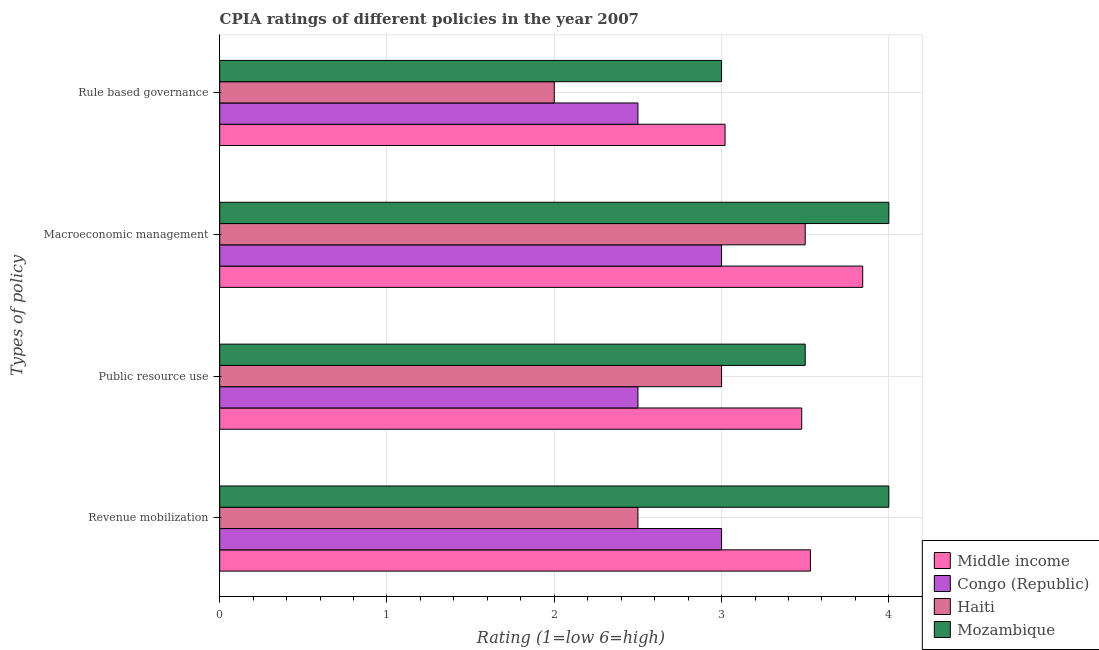How many different coloured bars are there?
Offer a terse response. 4. Are the number of bars on each tick of the Y-axis equal?
Provide a short and direct response. Yes. How many bars are there on the 2nd tick from the top?
Offer a very short reply. 4. What is the label of the 2nd group of bars from the top?
Offer a very short reply. Macroeconomic management. What is the cpia rating of macroeconomic management in Middle income?
Offer a terse response. 3.84. Across all countries, what is the maximum cpia rating of macroeconomic management?
Your answer should be very brief. 4. Across all countries, what is the minimum cpia rating of revenue mobilization?
Your answer should be compact. 2.5. In which country was the cpia rating of macroeconomic management maximum?
Make the answer very short. Mozambique. In which country was the cpia rating of macroeconomic management minimum?
Keep it short and to the point. Congo (Republic). What is the total cpia rating of public resource use in the graph?
Your answer should be compact. 12.48. What is the difference between the cpia rating of revenue mobilization in Middle income and the cpia rating of rule based governance in Haiti?
Provide a succinct answer. 1.53. What is the average cpia rating of macroeconomic management per country?
Your answer should be compact. 3.59. What is the ratio of the cpia rating of public resource use in Congo (Republic) to that in Middle income?
Offer a very short reply. 0.72. Is the difference between the cpia rating of macroeconomic management in Middle income and Congo (Republic) greater than the difference between the cpia rating of public resource use in Middle income and Congo (Republic)?
Ensure brevity in your answer.  No. What is the difference between the highest and the second highest cpia rating of public resource use?
Your response must be concise. 0.02. In how many countries, is the cpia rating of public resource use greater than the average cpia rating of public resource use taken over all countries?
Keep it short and to the point. 2. Is the sum of the cpia rating of public resource use in Middle income and Haiti greater than the maximum cpia rating of rule based governance across all countries?
Make the answer very short. Yes. What does the 2nd bar from the top in Revenue mobilization represents?
Give a very brief answer. Haiti. What does the 4th bar from the bottom in Macroeconomic management represents?
Provide a succinct answer. Mozambique. How many bars are there?
Provide a succinct answer. 16. What is the difference between two consecutive major ticks on the X-axis?
Offer a terse response. 1. Are the values on the major ticks of X-axis written in scientific E-notation?
Your answer should be compact. No. Does the graph contain grids?
Your response must be concise. Yes. How many legend labels are there?
Offer a terse response. 4. What is the title of the graph?
Ensure brevity in your answer.  CPIA ratings of different policies in the year 2007. What is the label or title of the Y-axis?
Ensure brevity in your answer.  Types of policy. What is the Rating (1=low 6=high) of Middle income in Revenue mobilization?
Keep it short and to the point. 3.53. What is the Rating (1=low 6=high) in Haiti in Revenue mobilization?
Your answer should be very brief. 2.5. What is the Rating (1=low 6=high) of Middle income in Public resource use?
Your answer should be very brief. 3.48. What is the Rating (1=low 6=high) in Congo (Republic) in Public resource use?
Your answer should be very brief. 2.5. What is the Rating (1=low 6=high) in Haiti in Public resource use?
Offer a terse response. 3. What is the Rating (1=low 6=high) of Mozambique in Public resource use?
Make the answer very short. 3.5. What is the Rating (1=low 6=high) in Middle income in Macroeconomic management?
Your answer should be compact. 3.84. What is the Rating (1=low 6=high) of Congo (Republic) in Macroeconomic management?
Your answer should be very brief. 3. What is the Rating (1=low 6=high) of Middle income in Rule based governance?
Offer a very short reply. 3.02. What is the Rating (1=low 6=high) of Haiti in Rule based governance?
Offer a terse response. 2. Across all Types of policy, what is the maximum Rating (1=low 6=high) in Middle income?
Offer a very short reply. 3.84. Across all Types of policy, what is the maximum Rating (1=low 6=high) in Congo (Republic)?
Keep it short and to the point. 3. Across all Types of policy, what is the maximum Rating (1=low 6=high) of Mozambique?
Your answer should be very brief. 4. Across all Types of policy, what is the minimum Rating (1=low 6=high) in Middle income?
Your answer should be very brief. 3.02. What is the total Rating (1=low 6=high) in Middle income in the graph?
Offer a terse response. 13.88. What is the total Rating (1=low 6=high) in Congo (Republic) in the graph?
Provide a succinct answer. 11. What is the total Rating (1=low 6=high) in Haiti in the graph?
Keep it short and to the point. 11. What is the total Rating (1=low 6=high) in Mozambique in the graph?
Give a very brief answer. 14.5. What is the difference between the Rating (1=low 6=high) in Middle income in Revenue mobilization and that in Public resource use?
Provide a short and direct response. 0.05. What is the difference between the Rating (1=low 6=high) of Congo (Republic) in Revenue mobilization and that in Public resource use?
Keep it short and to the point. 0.5. What is the difference between the Rating (1=low 6=high) of Haiti in Revenue mobilization and that in Public resource use?
Ensure brevity in your answer.  -0.5. What is the difference between the Rating (1=low 6=high) in Middle income in Revenue mobilization and that in Macroeconomic management?
Your answer should be compact. -0.31. What is the difference between the Rating (1=low 6=high) of Congo (Republic) in Revenue mobilization and that in Macroeconomic management?
Give a very brief answer. 0. What is the difference between the Rating (1=low 6=high) in Middle income in Revenue mobilization and that in Rule based governance?
Your response must be concise. 0.51. What is the difference between the Rating (1=low 6=high) of Mozambique in Revenue mobilization and that in Rule based governance?
Give a very brief answer. 1. What is the difference between the Rating (1=low 6=high) in Middle income in Public resource use and that in Macroeconomic management?
Your response must be concise. -0.36. What is the difference between the Rating (1=low 6=high) in Mozambique in Public resource use and that in Macroeconomic management?
Ensure brevity in your answer.  -0.5. What is the difference between the Rating (1=low 6=high) of Middle income in Public resource use and that in Rule based governance?
Give a very brief answer. 0.46. What is the difference between the Rating (1=low 6=high) in Congo (Republic) in Public resource use and that in Rule based governance?
Offer a terse response. 0. What is the difference between the Rating (1=low 6=high) in Haiti in Public resource use and that in Rule based governance?
Keep it short and to the point. 1. What is the difference between the Rating (1=low 6=high) of Middle income in Macroeconomic management and that in Rule based governance?
Offer a very short reply. 0.82. What is the difference between the Rating (1=low 6=high) in Congo (Republic) in Macroeconomic management and that in Rule based governance?
Provide a short and direct response. 0.5. What is the difference between the Rating (1=low 6=high) in Mozambique in Macroeconomic management and that in Rule based governance?
Your answer should be compact. 1. What is the difference between the Rating (1=low 6=high) in Middle income in Revenue mobilization and the Rating (1=low 6=high) in Congo (Republic) in Public resource use?
Offer a terse response. 1.03. What is the difference between the Rating (1=low 6=high) in Middle income in Revenue mobilization and the Rating (1=low 6=high) in Haiti in Public resource use?
Make the answer very short. 0.53. What is the difference between the Rating (1=low 6=high) in Middle income in Revenue mobilization and the Rating (1=low 6=high) in Mozambique in Public resource use?
Keep it short and to the point. 0.03. What is the difference between the Rating (1=low 6=high) of Congo (Republic) in Revenue mobilization and the Rating (1=low 6=high) of Haiti in Public resource use?
Ensure brevity in your answer.  0. What is the difference between the Rating (1=low 6=high) in Congo (Republic) in Revenue mobilization and the Rating (1=low 6=high) in Mozambique in Public resource use?
Provide a short and direct response. -0.5. What is the difference between the Rating (1=low 6=high) in Middle income in Revenue mobilization and the Rating (1=low 6=high) in Congo (Republic) in Macroeconomic management?
Your response must be concise. 0.53. What is the difference between the Rating (1=low 6=high) in Middle income in Revenue mobilization and the Rating (1=low 6=high) in Haiti in Macroeconomic management?
Offer a terse response. 0.03. What is the difference between the Rating (1=low 6=high) of Middle income in Revenue mobilization and the Rating (1=low 6=high) of Mozambique in Macroeconomic management?
Offer a very short reply. -0.47. What is the difference between the Rating (1=low 6=high) in Congo (Republic) in Revenue mobilization and the Rating (1=low 6=high) in Haiti in Macroeconomic management?
Your answer should be very brief. -0.5. What is the difference between the Rating (1=low 6=high) in Congo (Republic) in Revenue mobilization and the Rating (1=low 6=high) in Mozambique in Macroeconomic management?
Offer a very short reply. -1. What is the difference between the Rating (1=low 6=high) of Middle income in Revenue mobilization and the Rating (1=low 6=high) of Congo (Republic) in Rule based governance?
Offer a terse response. 1.03. What is the difference between the Rating (1=low 6=high) of Middle income in Revenue mobilization and the Rating (1=low 6=high) of Haiti in Rule based governance?
Provide a succinct answer. 1.53. What is the difference between the Rating (1=low 6=high) of Middle income in Revenue mobilization and the Rating (1=low 6=high) of Mozambique in Rule based governance?
Keep it short and to the point. 0.53. What is the difference between the Rating (1=low 6=high) of Congo (Republic) in Revenue mobilization and the Rating (1=low 6=high) of Haiti in Rule based governance?
Provide a short and direct response. 1. What is the difference between the Rating (1=low 6=high) in Congo (Republic) in Revenue mobilization and the Rating (1=low 6=high) in Mozambique in Rule based governance?
Provide a succinct answer. 0. What is the difference between the Rating (1=low 6=high) of Middle income in Public resource use and the Rating (1=low 6=high) of Congo (Republic) in Macroeconomic management?
Your response must be concise. 0.48. What is the difference between the Rating (1=low 6=high) in Middle income in Public resource use and the Rating (1=low 6=high) in Haiti in Macroeconomic management?
Keep it short and to the point. -0.02. What is the difference between the Rating (1=low 6=high) in Middle income in Public resource use and the Rating (1=low 6=high) in Mozambique in Macroeconomic management?
Provide a succinct answer. -0.52. What is the difference between the Rating (1=low 6=high) of Congo (Republic) in Public resource use and the Rating (1=low 6=high) of Haiti in Macroeconomic management?
Your answer should be very brief. -1. What is the difference between the Rating (1=low 6=high) in Middle income in Public resource use and the Rating (1=low 6=high) in Congo (Republic) in Rule based governance?
Ensure brevity in your answer.  0.98. What is the difference between the Rating (1=low 6=high) in Middle income in Public resource use and the Rating (1=low 6=high) in Haiti in Rule based governance?
Your response must be concise. 1.48. What is the difference between the Rating (1=low 6=high) of Middle income in Public resource use and the Rating (1=low 6=high) of Mozambique in Rule based governance?
Your response must be concise. 0.48. What is the difference between the Rating (1=low 6=high) in Congo (Republic) in Public resource use and the Rating (1=low 6=high) in Haiti in Rule based governance?
Offer a very short reply. 0.5. What is the difference between the Rating (1=low 6=high) in Haiti in Public resource use and the Rating (1=low 6=high) in Mozambique in Rule based governance?
Your response must be concise. 0. What is the difference between the Rating (1=low 6=high) in Middle income in Macroeconomic management and the Rating (1=low 6=high) in Congo (Republic) in Rule based governance?
Provide a succinct answer. 1.34. What is the difference between the Rating (1=low 6=high) in Middle income in Macroeconomic management and the Rating (1=low 6=high) in Haiti in Rule based governance?
Your answer should be very brief. 1.84. What is the difference between the Rating (1=low 6=high) of Middle income in Macroeconomic management and the Rating (1=low 6=high) of Mozambique in Rule based governance?
Your answer should be very brief. 0.84. What is the difference between the Rating (1=low 6=high) in Congo (Republic) in Macroeconomic management and the Rating (1=low 6=high) in Haiti in Rule based governance?
Offer a very short reply. 1. What is the difference between the Rating (1=low 6=high) in Congo (Republic) in Macroeconomic management and the Rating (1=low 6=high) in Mozambique in Rule based governance?
Give a very brief answer. 0. What is the difference between the Rating (1=low 6=high) of Haiti in Macroeconomic management and the Rating (1=low 6=high) of Mozambique in Rule based governance?
Provide a short and direct response. 0.5. What is the average Rating (1=low 6=high) of Middle income per Types of policy?
Your answer should be very brief. 3.47. What is the average Rating (1=low 6=high) of Congo (Republic) per Types of policy?
Give a very brief answer. 2.75. What is the average Rating (1=low 6=high) of Haiti per Types of policy?
Offer a terse response. 2.75. What is the average Rating (1=low 6=high) of Mozambique per Types of policy?
Your response must be concise. 3.62. What is the difference between the Rating (1=low 6=high) of Middle income and Rating (1=low 6=high) of Congo (Republic) in Revenue mobilization?
Your answer should be very brief. 0.53. What is the difference between the Rating (1=low 6=high) in Middle income and Rating (1=low 6=high) in Haiti in Revenue mobilization?
Provide a short and direct response. 1.03. What is the difference between the Rating (1=low 6=high) of Middle income and Rating (1=low 6=high) of Mozambique in Revenue mobilization?
Ensure brevity in your answer.  -0.47. What is the difference between the Rating (1=low 6=high) in Congo (Republic) and Rating (1=low 6=high) in Mozambique in Revenue mobilization?
Your answer should be compact. -1. What is the difference between the Rating (1=low 6=high) of Middle income and Rating (1=low 6=high) of Congo (Republic) in Public resource use?
Give a very brief answer. 0.98. What is the difference between the Rating (1=low 6=high) in Middle income and Rating (1=low 6=high) in Haiti in Public resource use?
Make the answer very short. 0.48. What is the difference between the Rating (1=low 6=high) in Middle income and Rating (1=low 6=high) in Mozambique in Public resource use?
Make the answer very short. -0.02. What is the difference between the Rating (1=low 6=high) in Congo (Republic) and Rating (1=low 6=high) in Haiti in Public resource use?
Your answer should be very brief. -0.5. What is the difference between the Rating (1=low 6=high) of Middle income and Rating (1=low 6=high) of Congo (Republic) in Macroeconomic management?
Keep it short and to the point. 0.84. What is the difference between the Rating (1=low 6=high) of Middle income and Rating (1=low 6=high) of Haiti in Macroeconomic management?
Offer a terse response. 0.34. What is the difference between the Rating (1=low 6=high) of Middle income and Rating (1=low 6=high) of Mozambique in Macroeconomic management?
Your response must be concise. -0.16. What is the difference between the Rating (1=low 6=high) in Congo (Republic) and Rating (1=low 6=high) in Haiti in Macroeconomic management?
Offer a very short reply. -0.5. What is the difference between the Rating (1=low 6=high) in Congo (Republic) and Rating (1=low 6=high) in Mozambique in Macroeconomic management?
Provide a succinct answer. -1. What is the difference between the Rating (1=low 6=high) of Middle income and Rating (1=low 6=high) of Congo (Republic) in Rule based governance?
Ensure brevity in your answer.  0.52. What is the difference between the Rating (1=low 6=high) in Middle income and Rating (1=low 6=high) in Haiti in Rule based governance?
Your answer should be compact. 1.02. What is the difference between the Rating (1=low 6=high) of Middle income and Rating (1=low 6=high) of Mozambique in Rule based governance?
Give a very brief answer. 0.02. What is the difference between the Rating (1=low 6=high) of Congo (Republic) and Rating (1=low 6=high) of Haiti in Rule based governance?
Offer a terse response. 0.5. What is the difference between the Rating (1=low 6=high) of Haiti and Rating (1=low 6=high) of Mozambique in Rule based governance?
Ensure brevity in your answer.  -1. What is the ratio of the Rating (1=low 6=high) of Congo (Republic) in Revenue mobilization to that in Public resource use?
Keep it short and to the point. 1.2. What is the ratio of the Rating (1=low 6=high) of Haiti in Revenue mobilization to that in Public resource use?
Your response must be concise. 0.83. What is the ratio of the Rating (1=low 6=high) in Middle income in Revenue mobilization to that in Macroeconomic management?
Make the answer very short. 0.92. What is the ratio of the Rating (1=low 6=high) in Mozambique in Revenue mobilization to that in Macroeconomic management?
Offer a very short reply. 1. What is the ratio of the Rating (1=low 6=high) in Middle income in Revenue mobilization to that in Rule based governance?
Keep it short and to the point. 1.17. What is the ratio of the Rating (1=low 6=high) of Congo (Republic) in Revenue mobilization to that in Rule based governance?
Provide a succinct answer. 1.2. What is the ratio of the Rating (1=low 6=high) in Haiti in Revenue mobilization to that in Rule based governance?
Offer a terse response. 1.25. What is the ratio of the Rating (1=low 6=high) of Middle income in Public resource use to that in Macroeconomic management?
Offer a very short reply. 0.91. What is the ratio of the Rating (1=low 6=high) of Congo (Republic) in Public resource use to that in Macroeconomic management?
Your response must be concise. 0.83. What is the ratio of the Rating (1=low 6=high) of Mozambique in Public resource use to that in Macroeconomic management?
Keep it short and to the point. 0.88. What is the ratio of the Rating (1=low 6=high) of Middle income in Public resource use to that in Rule based governance?
Ensure brevity in your answer.  1.15. What is the ratio of the Rating (1=low 6=high) in Haiti in Public resource use to that in Rule based governance?
Make the answer very short. 1.5. What is the ratio of the Rating (1=low 6=high) in Mozambique in Public resource use to that in Rule based governance?
Keep it short and to the point. 1.17. What is the ratio of the Rating (1=low 6=high) of Middle income in Macroeconomic management to that in Rule based governance?
Ensure brevity in your answer.  1.27. What is the ratio of the Rating (1=low 6=high) of Congo (Republic) in Macroeconomic management to that in Rule based governance?
Offer a terse response. 1.2. What is the ratio of the Rating (1=low 6=high) in Mozambique in Macroeconomic management to that in Rule based governance?
Offer a very short reply. 1.33. What is the difference between the highest and the second highest Rating (1=low 6=high) of Middle income?
Ensure brevity in your answer.  0.31. What is the difference between the highest and the lowest Rating (1=low 6=high) in Middle income?
Your answer should be compact. 0.82. What is the difference between the highest and the lowest Rating (1=low 6=high) in Mozambique?
Offer a terse response. 1. 